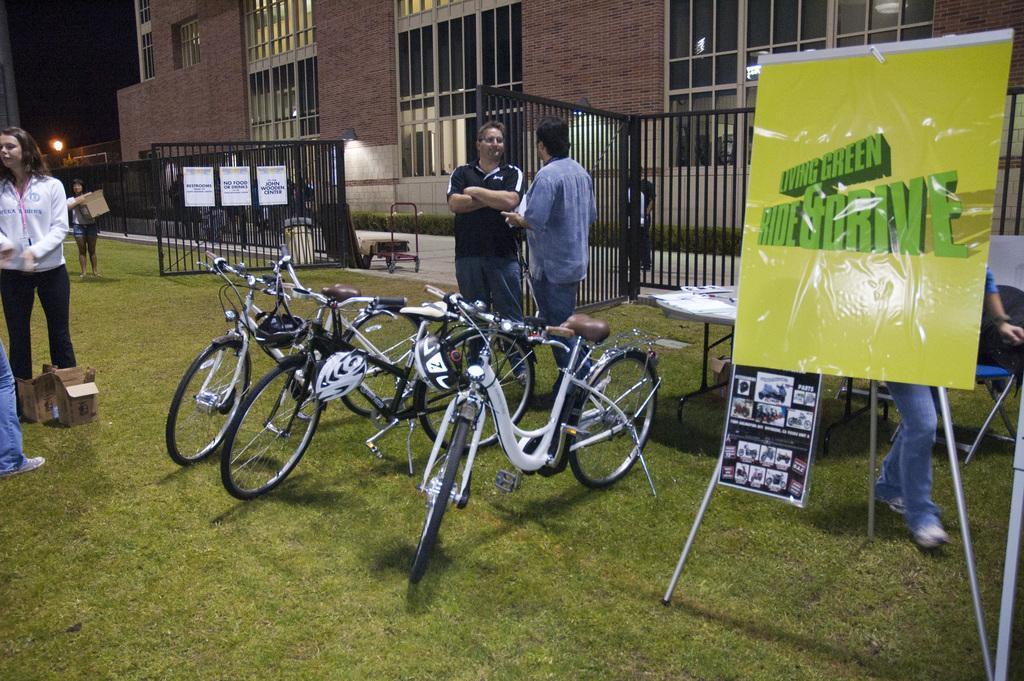Please provide a concise description of this image. In this image, we can see a few people standing on the ground covered with grass. We can also see bicycles and some cardboard boxes. On the right, we can see a poster with some text written on it. There is a fencing with some posters on it. We can also see a building. 